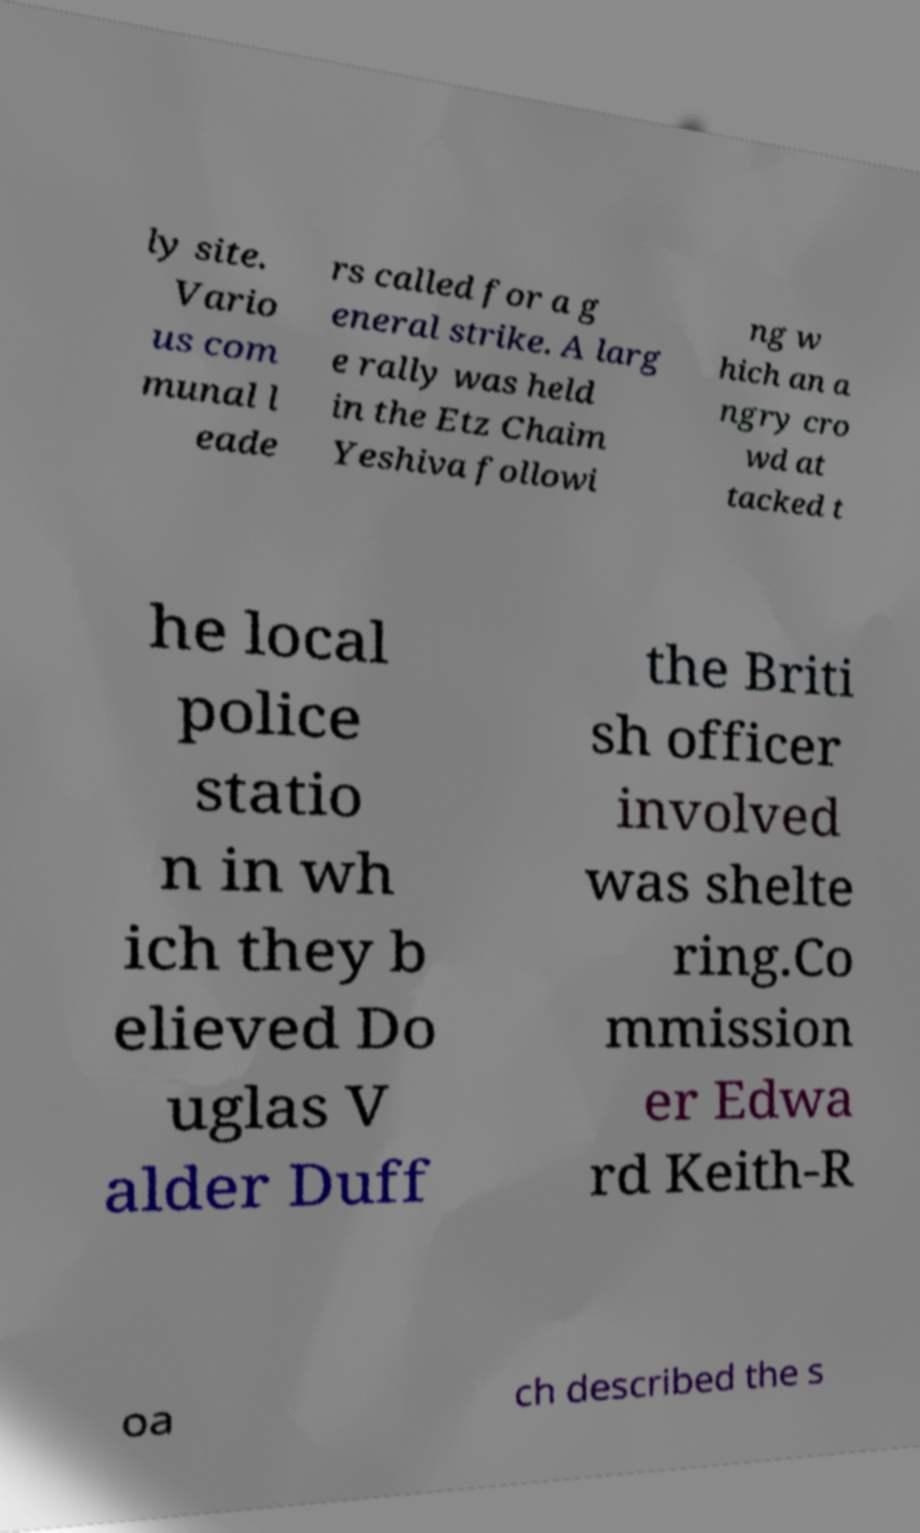There's text embedded in this image that I need extracted. Can you transcribe it verbatim? ly site. Vario us com munal l eade rs called for a g eneral strike. A larg e rally was held in the Etz Chaim Yeshiva followi ng w hich an a ngry cro wd at tacked t he local police statio n in wh ich they b elieved Do uglas V alder Duff the Briti sh officer involved was shelte ring.Co mmission er Edwa rd Keith-R oa ch described the s 